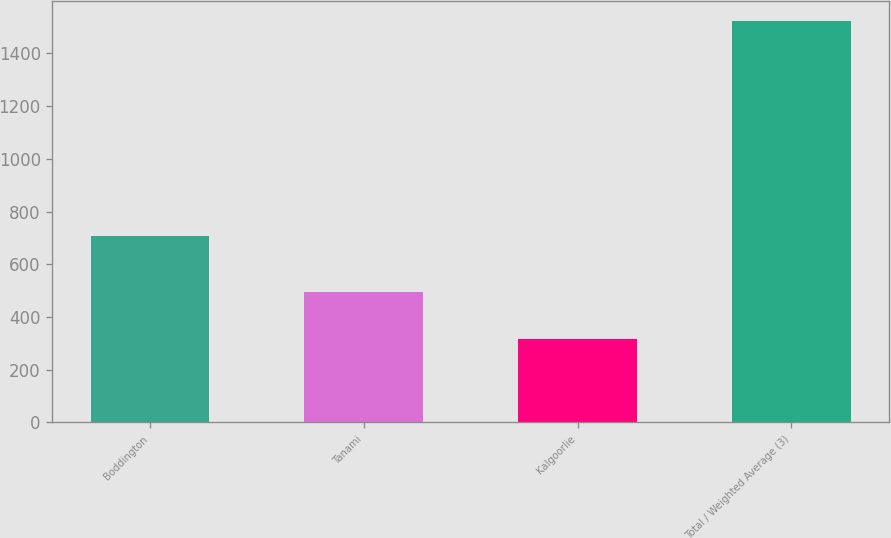Convert chart to OTSL. <chart><loc_0><loc_0><loc_500><loc_500><bar_chart><fcel>Boddington<fcel>Tanami<fcel>Kalgoorlie<fcel>Total / Weighted Average (3)<nl><fcel>709<fcel>496<fcel>318<fcel>1523<nl></chart> 